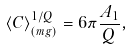Convert formula to latex. <formula><loc_0><loc_0><loc_500><loc_500>\langle C \rangle _ { ( m g ) } ^ { 1 / Q } = 6 \pi \frac { A _ { 1 } } { Q } ,</formula> 